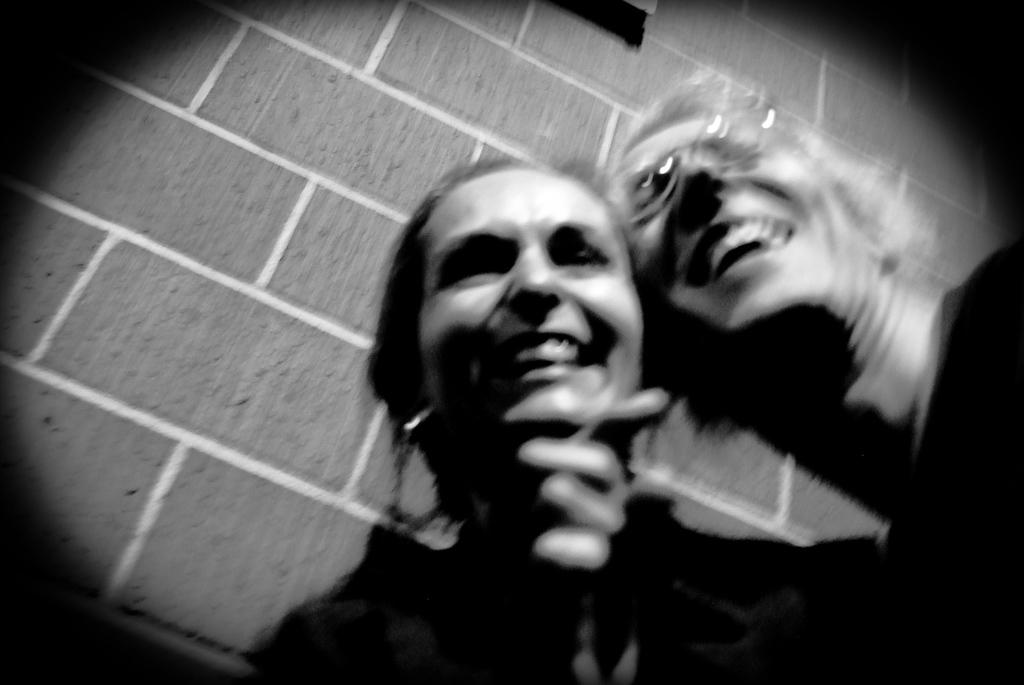What is the color scheme of the image? The image is black and white. Can you describe the people in the image? There is a man and a woman in the image, and both are smiling. What can be seen in the background of the image? There is a brick wall in the background of the image. What type of oven is visible in the image? There is no oven present in the image. Can you tell me how many sisters are in the image? The image does not depict any sisters, as it only features a man and a woman. 